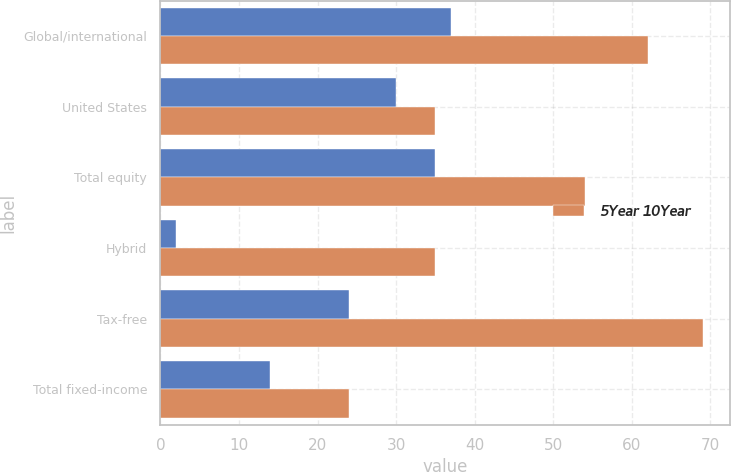<chart> <loc_0><loc_0><loc_500><loc_500><stacked_bar_chart><ecel><fcel>Global/international<fcel>United States<fcel>Total equity<fcel>Hybrid<fcel>Tax-free<fcel>Total fixed-income<nl><fcel>nan<fcel>37<fcel>30<fcel>35<fcel>2<fcel>24<fcel>14<nl><fcel>5Year 10Year<fcel>62<fcel>35<fcel>54<fcel>35<fcel>69<fcel>24<nl></chart> 